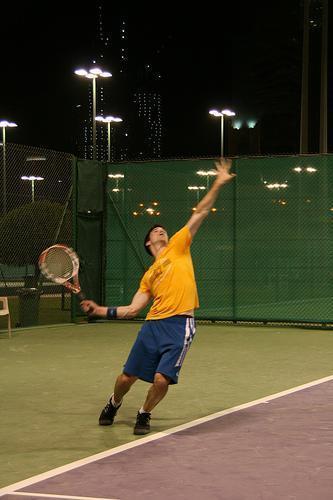How many people are there?
Give a very brief answer. 1. 